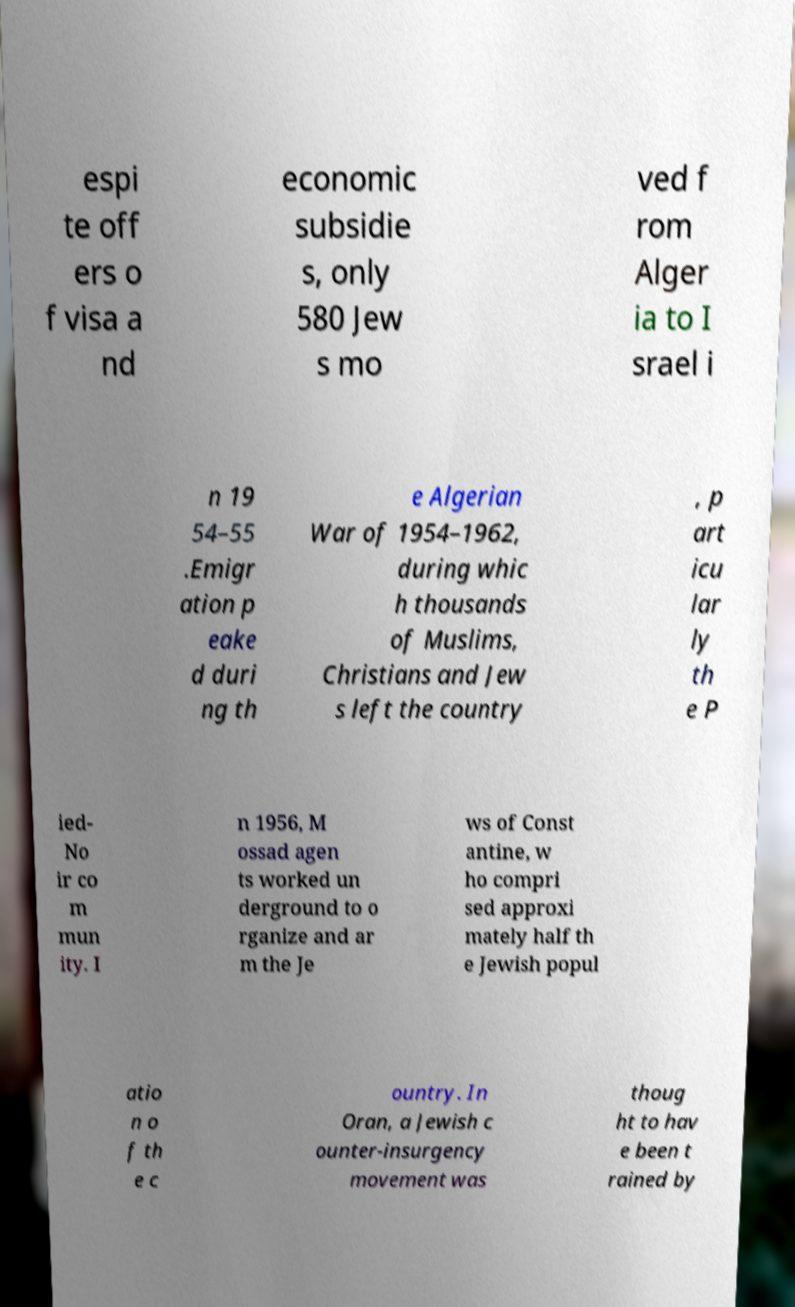For documentation purposes, I need the text within this image transcribed. Could you provide that? espi te off ers o f visa a nd economic subsidie s, only 580 Jew s mo ved f rom Alger ia to I srael i n 19 54–55 .Emigr ation p eake d duri ng th e Algerian War of 1954–1962, during whic h thousands of Muslims, Christians and Jew s left the country , p art icu lar ly th e P ied- No ir co m mun ity. I n 1956, M ossad agen ts worked un derground to o rganize and ar m the Je ws of Const antine, w ho compri sed approxi mately half th e Jewish popul atio n o f th e c ountry. In Oran, a Jewish c ounter-insurgency movement was thoug ht to hav e been t rained by 